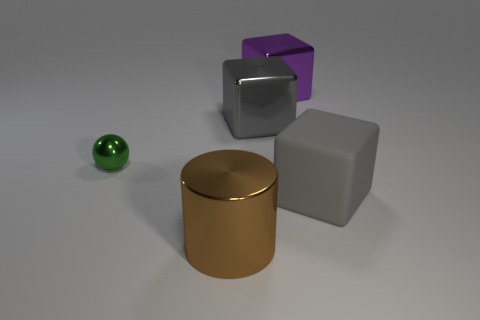How many other objects are there of the same shape as the big brown object?
Provide a short and direct response. 0. What is the color of the metal object that is both in front of the gray metallic cube and on the right side of the small green thing?
Your answer should be compact. Brown. The matte thing has what color?
Provide a succinct answer. Gray. Do the brown thing and the object that is to the left of the large metallic cylinder have the same material?
Make the answer very short. Yes. There is a tiny green object that is made of the same material as the large purple cube; what is its shape?
Your answer should be very brief. Sphere. There is a cylinder that is the same size as the gray rubber block; what is its color?
Make the answer very short. Brown. Is the size of the gray cube that is left of the gray matte cube the same as the large gray matte thing?
Provide a succinct answer. Yes. What number of small purple shiny balls are there?
Provide a succinct answer. 0. How many balls are either matte things or big purple metallic things?
Provide a short and direct response. 0. There is a object left of the brown metallic cylinder; what number of large cylinders are behind it?
Offer a very short reply. 0. 